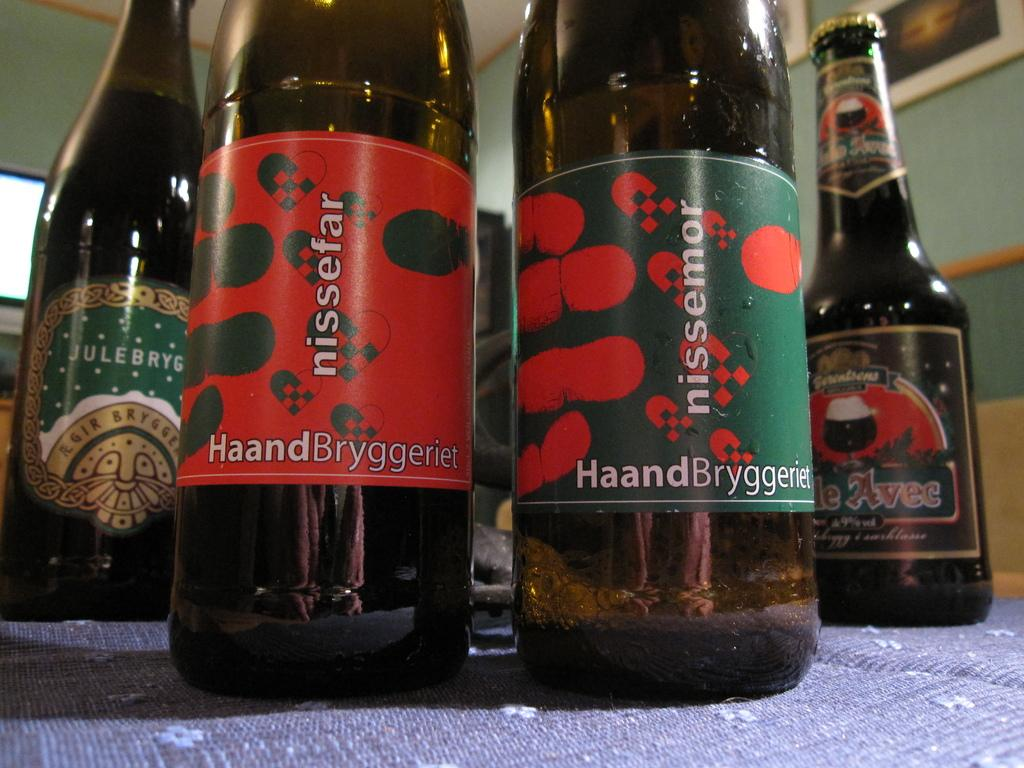<image>
Write a terse but informative summary of the picture. 4 bottles standing next to each other with nissefar displayed in front 